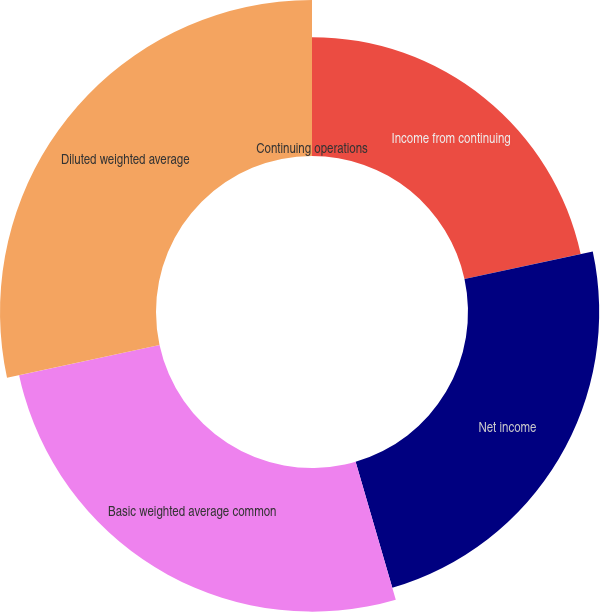<chart> <loc_0><loc_0><loc_500><loc_500><pie_chart><fcel>Income from continuing<fcel>Net income<fcel>Basic weighted average common<fcel>Diluted weighted average<fcel>Continuing operations<nl><fcel>21.62%<fcel>23.87%<fcel>26.13%<fcel>28.38%<fcel>0.0%<nl></chart> 